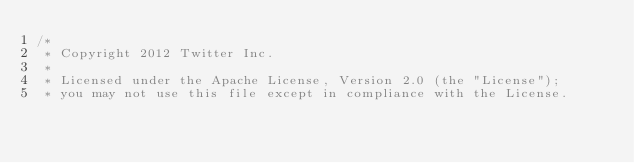<code> <loc_0><loc_0><loc_500><loc_500><_Scala_>/*
 * Copyright 2012 Twitter Inc.
 * 
 * Licensed under the Apache License, Version 2.0 (the "License");
 * you may not use this file except in compliance with the License.</code> 